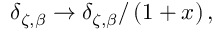Convert formula to latex. <formula><loc_0><loc_0><loc_500><loc_500>\delta _ { \zeta , \beta } \rightarrow \delta _ { \zeta , \beta } / \left ( 1 + x \right ) ,</formula> 